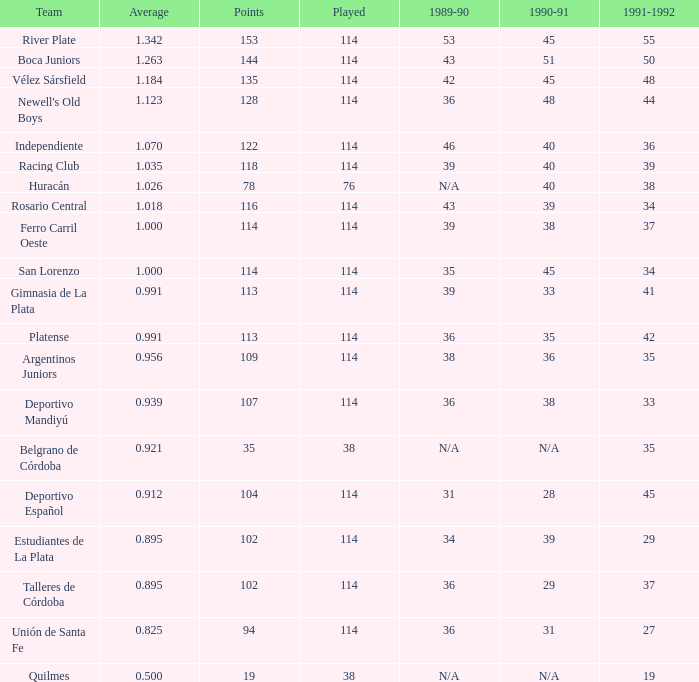How much 1991-1992 has a 1989-90 of 36, and an Average of 0.8250000000000001? 0.0. 